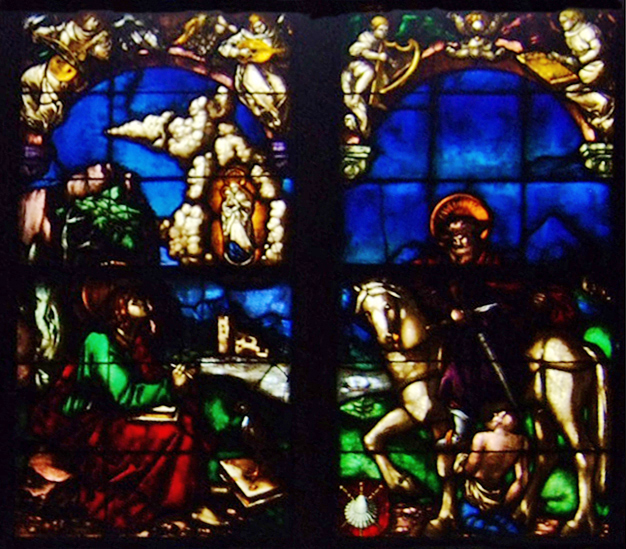What is this photo about'? The image showcases a beautiful stained glass window, divided into two panels with arched tops. The panels are separated by a thin stone mullion, adding a touch of architectural elegance to the overall design. 

In the left panel, a man in a vibrant green robe is depicted kneeling before a woman dressed in a rich red robe. The woman holds a book and a lily, symbols often associated with knowledge and purity. 

The right panel mirrors the left in composition, but with a change in color scheme. Here, a man in a striking red robe kneels before a woman in a serene blue robe. Just like her counterpart in the left panel, she too holds a book and a lily.

The colors used are predominantly red, blue, and green, with gold and white accents adding depth and contrast. The art style is distinctly Gothic, characterized by the ornate stone tracery framing the panels. The genre of the art is religious, as suggested by the symbolic elements and the reverent poses of the figures. 